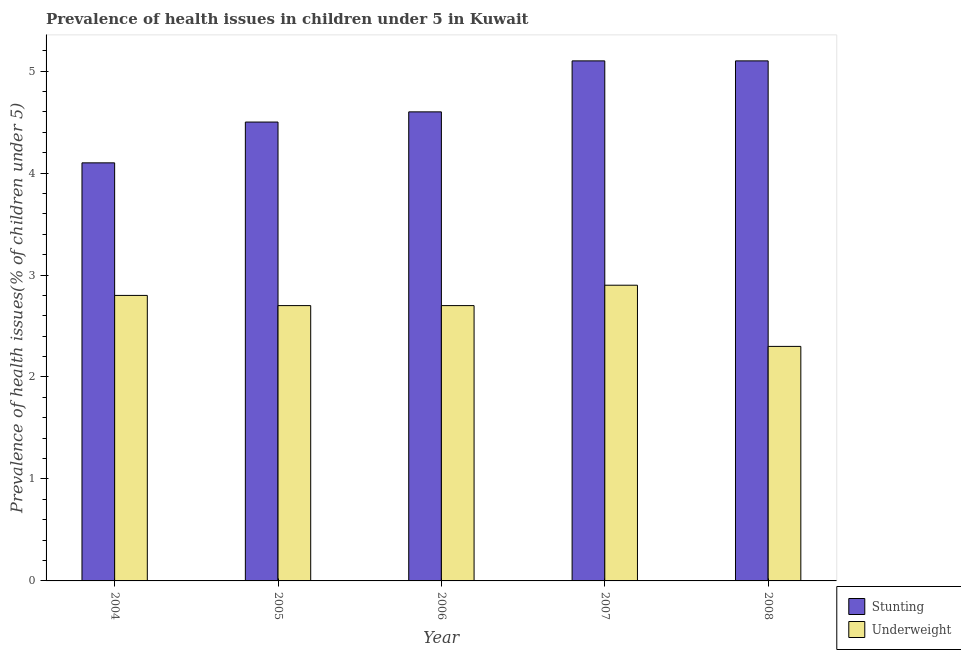Are the number of bars per tick equal to the number of legend labels?
Ensure brevity in your answer.  Yes. Are the number of bars on each tick of the X-axis equal?
Provide a succinct answer. Yes. How many bars are there on the 4th tick from the right?
Ensure brevity in your answer.  2. In how many cases, is the number of bars for a given year not equal to the number of legend labels?
Keep it short and to the point. 0. What is the percentage of stunted children in 2006?
Your answer should be compact. 4.6. Across all years, what is the maximum percentage of underweight children?
Keep it short and to the point. 2.9. Across all years, what is the minimum percentage of underweight children?
Your response must be concise. 2.3. In which year was the percentage of stunted children maximum?
Your answer should be very brief. 2007. What is the total percentage of stunted children in the graph?
Provide a succinct answer. 23.4. What is the difference between the percentage of underweight children in 2004 and that in 2006?
Your answer should be compact. 0.1. What is the difference between the percentage of underweight children in 2005 and the percentage of stunted children in 2008?
Your response must be concise. 0.4. What is the average percentage of stunted children per year?
Give a very brief answer. 4.68. In the year 2005, what is the difference between the percentage of stunted children and percentage of underweight children?
Your answer should be very brief. 0. What is the ratio of the percentage of stunted children in 2004 to that in 2007?
Your response must be concise. 0.8. Is the percentage of stunted children in 2005 less than that in 2006?
Provide a short and direct response. Yes. What is the difference between the highest and the second highest percentage of underweight children?
Ensure brevity in your answer.  0.1. What is the difference between the highest and the lowest percentage of underweight children?
Provide a short and direct response. 0.6. In how many years, is the percentage of underweight children greater than the average percentage of underweight children taken over all years?
Make the answer very short. 4. Is the sum of the percentage of stunted children in 2004 and 2006 greater than the maximum percentage of underweight children across all years?
Give a very brief answer. Yes. What does the 2nd bar from the left in 2007 represents?
Provide a short and direct response. Underweight. What does the 2nd bar from the right in 2007 represents?
Your response must be concise. Stunting. How many bars are there?
Your response must be concise. 10. Are all the bars in the graph horizontal?
Keep it short and to the point. No. How many years are there in the graph?
Provide a short and direct response. 5. Are the values on the major ticks of Y-axis written in scientific E-notation?
Ensure brevity in your answer.  No. How many legend labels are there?
Offer a very short reply. 2. What is the title of the graph?
Your answer should be compact. Prevalence of health issues in children under 5 in Kuwait. Does "Time to export" appear as one of the legend labels in the graph?
Your answer should be very brief. No. What is the label or title of the Y-axis?
Your answer should be compact. Prevalence of health issues(% of children under 5). What is the Prevalence of health issues(% of children under 5) of Stunting in 2004?
Give a very brief answer. 4.1. What is the Prevalence of health issues(% of children under 5) in Underweight in 2004?
Make the answer very short. 2.8. What is the Prevalence of health issues(% of children under 5) in Stunting in 2005?
Give a very brief answer. 4.5. What is the Prevalence of health issues(% of children under 5) of Underweight in 2005?
Offer a terse response. 2.7. What is the Prevalence of health issues(% of children under 5) in Stunting in 2006?
Offer a terse response. 4.6. What is the Prevalence of health issues(% of children under 5) in Underweight in 2006?
Offer a very short reply. 2.7. What is the Prevalence of health issues(% of children under 5) of Stunting in 2007?
Keep it short and to the point. 5.1. What is the Prevalence of health issues(% of children under 5) in Underweight in 2007?
Make the answer very short. 2.9. What is the Prevalence of health issues(% of children under 5) of Stunting in 2008?
Provide a short and direct response. 5.1. What is the Prevalence of health issues(% of children under 5) in Underweight in 2008?
Provide a succinct answer. 2.3. Across all years, what is the maximum Prevalence of health issues(% of children under 5) in Stunting?
Make the answer very short. 5.1. Across all years, what is the maximum Prevalence of health issues(% of children under 5) in Underweight?
Give a very brief answer. 2.9. Across all years, what is the minimum Prevalence of health issues(% of children under 5) in Stunting?
Provide a succinct answer. 4.1. Across all years, what is the minimum Prevalence of health issues(% of children under 5) of Underweight?
Offer a very short reply. 2.3. What is the total Prevalence of health issues(% of children under 5) in Stunting in the graph?
Keep it short and to the point. 23.4. What is the total Prevalence of health issues(% of children under 5) of Underweight in the graph?
Provide a short and direct response. 13.4. What is the difference between the Prevalence of health issues(% of children under 5) in Underweight in 2004 and that in 2005?
Offer a terse response. 0.1. What is the difference between the Prevalence of health issues(% of children under 5) in Stunting in 2004 and that in 2006?
Offer a very short reply. -0.5. What is the difference between the Prevalence of health issues(% of children under 5) in Underweight in 2004 and that in 2006?
Offer a terse response. 0.1. What is the difference between the Prevalence of health issues(% of children under 5) in Stunting in 2004 and that in 2007?
Keep it short and to the point. -1. What is the difference between the Prevalence of health issues(% of children under 5) of Underweight in 2004 and that in 2008?
Provide a succinct answer. 0.5. What is the difference between the Prevalence of health issues(% of children under 5) in Underweight in 2005 and that in 2006?
Offer a very short reply. 0. What is the difference between the Prevalence of health issues(% of children under 5) in Underweight in 2005 and that in 2007?
Give a very brief answer. -0.2. What is the difference between the Prevalence of health issues(% of children under 5) of Stunting in 2006 and that in 2008?
Offer a very short reply. -0.5. What is the difference between the Prevalence of health issues(% of children under 5) of Underweight in 2006 and that in 2008?
Your response must be concise. 0.4. What is the difference between the Prevalence of health issues(% of children under 5) in Stunting in 2007 and that in 2008?
Your answer should be very brief. 0. What is the difference between the Prevalence of health issues(% of children under 5) in Stunting in 2004 and the Prevalence of health issues(% of children under 5) in Underweight in 2007?
Ensure brevity in your answer.  1.2. What is the difference between the Prevalence of health issues(% of children under 5) in Stunting in 2005 and the Prevalence of health issues(% of children under 5) in Underweight in 2006?
Provide a short and direct response. 1.8. What is the difference between the Prevalence of health issues(% of children under 5) in Stunting in 2005 and the Prevalence of health issues(% of children under 5) in Underweight in 2007?
Your answer should be compact. 1.6. What is the difference between the Prevalence of health issues(% of children under 5) in Stunting in 2006 and the Prevalence of health issues(% of children under 5) in Underweight in 2007?
Your answer should be very brief. 1.7. What is the difference between the Prevalence of health issues(% of children under 5) in Stunting in 2006 and the Prevalence of health issues(% of children under 5) in Underweight in 2008?
Keep it short and to the point. 2.3. What is the difference between the Prevalence of health issues(% of children under 5) in Stunting in 2007 and the Prevalence of health issues(% of children under 5) in Underweight in 2008?
Ensure brevity in your answer.  2.8. What is the average Prevalence of health issues(% of children under 5) of Stunting per year?
Your answer should be very brief. 4.68. What is the average Prevalence of health issues(% of children under 5) in Underweight per year?
Your response must be concise. 2.68. In the year 2004, what is the difference between the Prevalence of health issues(% of children under 5) of Stunting and Prevalence of health issues(% of children under 5) of Underweight?
Offer a terse response. 1.3. In the year 2005, what is the difference between the Prevalence of health issues(% of children under 5) of Stunting and Prevalence of health issues(% of children under 5) of Underweight?
Offer a terse response. 1.8. In the year 2006, what is the difference between the Prevalence of health issues(% of children under 5) in Stunting and Prevalence of health issues(% of children under 5) in Underweight?
Offer a very short reply. 1.9. In the year 2007, what is the difference between the Prevalence of health issues(% of children under 5) of Stunting and Prevalence of health issues(% of children under 5) of Underweight?
Offer a very short reply. 2.2. In the year 2008, what is the difference between the Prevalence of health issues(% of children under 5) in Stunting and Prevalence of health issues(% of children under 5) in Underweight?
Give a very brief answer. 2.8. What is the ratio of the Prevalence of health issues(% of children under 5) in Stunting in 2004 to that in 2005?
Keep it short and to the point. 0.91. What is the ratio of the Prevalence of health issues(% of children under 5) in Underweight in 2004 to that in 2005?
Give a very brief answer. 1.04. What is the ratio of the Prevalence of health issues(% of children under 5) in Stunting in 2004 to that in 2006?
Ensure brevity in your answer.  0.89. What is the ratio of the Prevalence of health issues(% of children under 5) in Stunting in 2004 to that in 2007?
Your response must be concise. 0.8. What is the ratio of the Prevalence of health issues(% of children under 5) of Underweight in 2004 to that in 2007?
Your answer should be compact. 0.97. What is the ratio of the Prevalence of health issues(% of children under 5) of Stunting in 2004 to that in 2008?
Make the answer very short. 0.8. What is the ratio of the Prevalence of health issues(% of children under 5) in Underweight in 2004 to that in 2008?
Provide a short and direct response. 1.22. What is the ratio of the Prevalence of health issues(% of children under 5) in Stunting in 2005 to that in 2006?
Offer a terse response. 0.98. What is the ratio of the Prevalence of health issues(% of children under 5) of Stunting in 2005 to that in 2007?
Ensure brevity in your answer.  0.88. What is the ratio of the Prevalence of health issues(% of children under 5) of Underweight in 2005 to that in 2007?
Provide a succinct answer. 0.93. What is the ratio of the Prevalence of health issues(% of children under 5) of Stunting in 2005 to that in 2008?
Your answer should be compact. 0.88. What is the ratio of the Prevalence of health issues(% of children under 5) of Underweight in 2005 to that in 2008?
Provide a short and direct response. 1.17. What is the ratio of the Prevalence of health issues(% of children under 5) of Stunting in 2006 to that in 2007?
Give a very brief answer. 0.9. What is the ratio of the Prevalence of health issues(% of children under 5) of Underweight in 2006 to that in 2007?
Offer a very short reply. 0.93. What is the ratio of the Prevalence of health issues(% of children under 5) of Stunting in 2006 to that in 2008?
Offer a terse response. 0.9. What is the ratio of the Prevalence of health issues(% of children under 5) in Underweight in 2006 to that in 2008?
Give a very brief answer. 1.17. What is the ratio of the Prevalence of health issues(% of children under 5) in Underweight in 2007 to that in 2008?
Your answer should be compact. 1.26. 